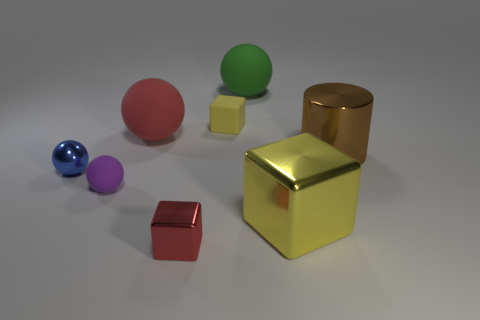How many other objects are there of the same color as the big shiny cube?
Your answer should be very brief. 1. What material is the other tiny object that is the same shape as the tiny red object?
Provide a short and direct response. Rubber. What number of tiny objects are either rubber blocks or red cubes?
Your answer should be very brief. 2. What is the material of the red ball?
Your answer should be compact. Rubber. There is a big object that is behind the brown thing and in front of the green rubber ball; what is its material?
Your response must be concise. Rubber. Do the tiny metallic block and the block that is to the right of the green rubber ball have the same color?
Your response must be concise. No. What is the material of the blue ball that is the same size as the yellow rubber cube?
Offer a terse response. Metal. Is there a green sphere that has the same material as the tiny purple ball?
Ensure brevity in your answer.  Yes. How many metallic cylinders are there?
Offer a very short reply. 1. Does the large red sphere have the same material as the large object in front of the blue metal ball?
Your answer should be compact. No. 